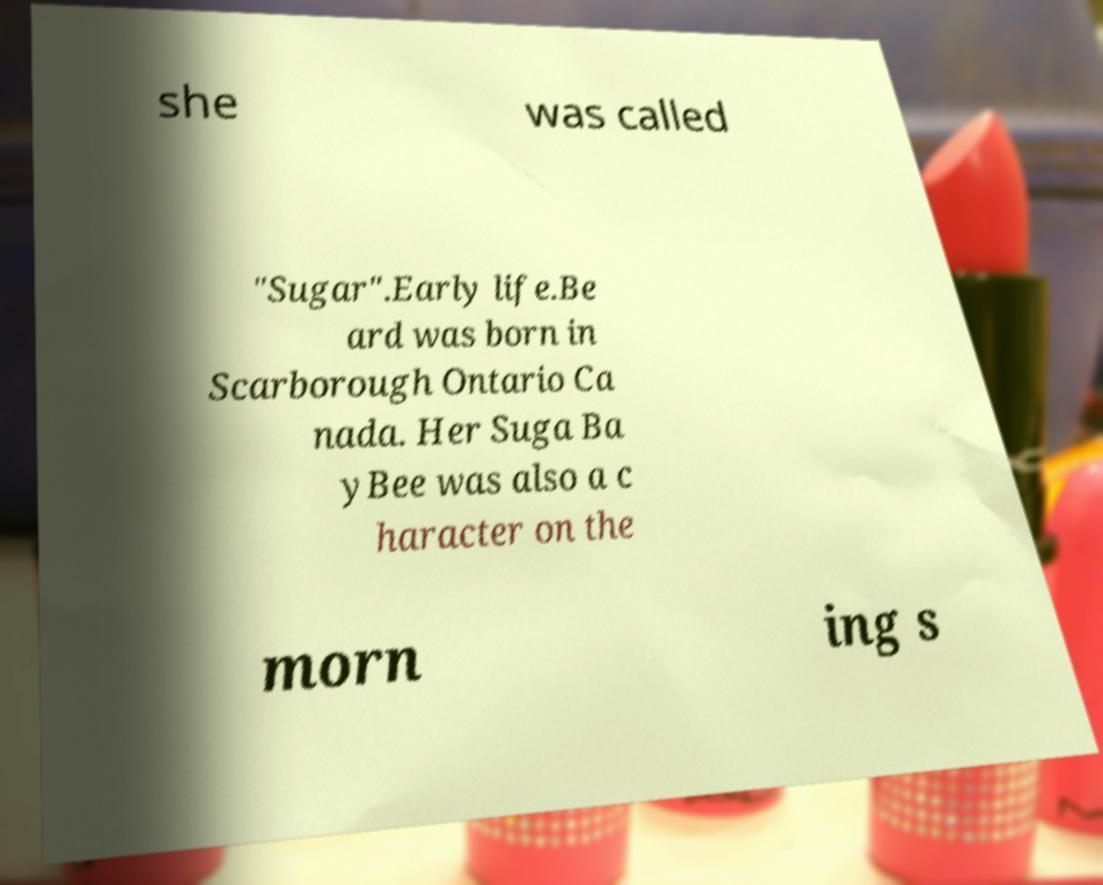Please identify and transcribe the text found in this image. she was called "Sugar".Early life.Be ard was born in Scarborough Ontario Ca nada. Her Suga Ba yBee was also a c haracter on the morn ing s 